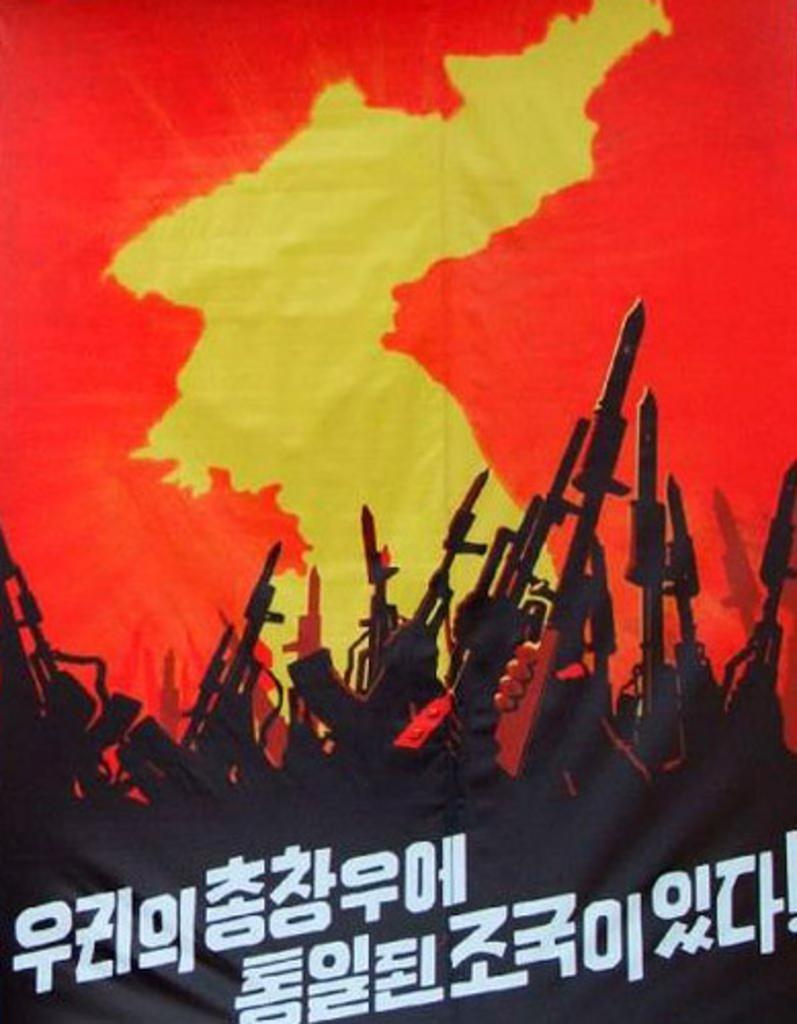Describe this image in one or two sentences. In the image we can see the poster, on the poster we can see text and picture of rifles. 